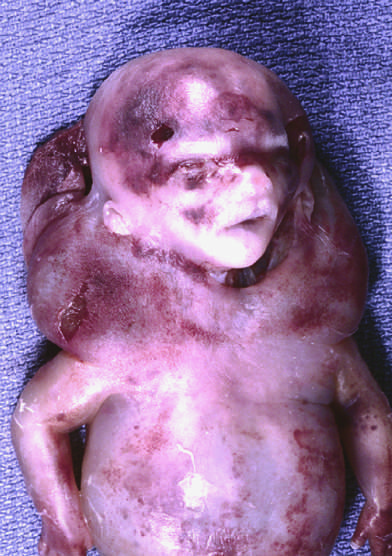re the light green polypeptides characteristically seen with, but not limited to, constitutional chromosomal anomalies such as 45, x karyotypes?
Answer the question using a single word or phrase. No 